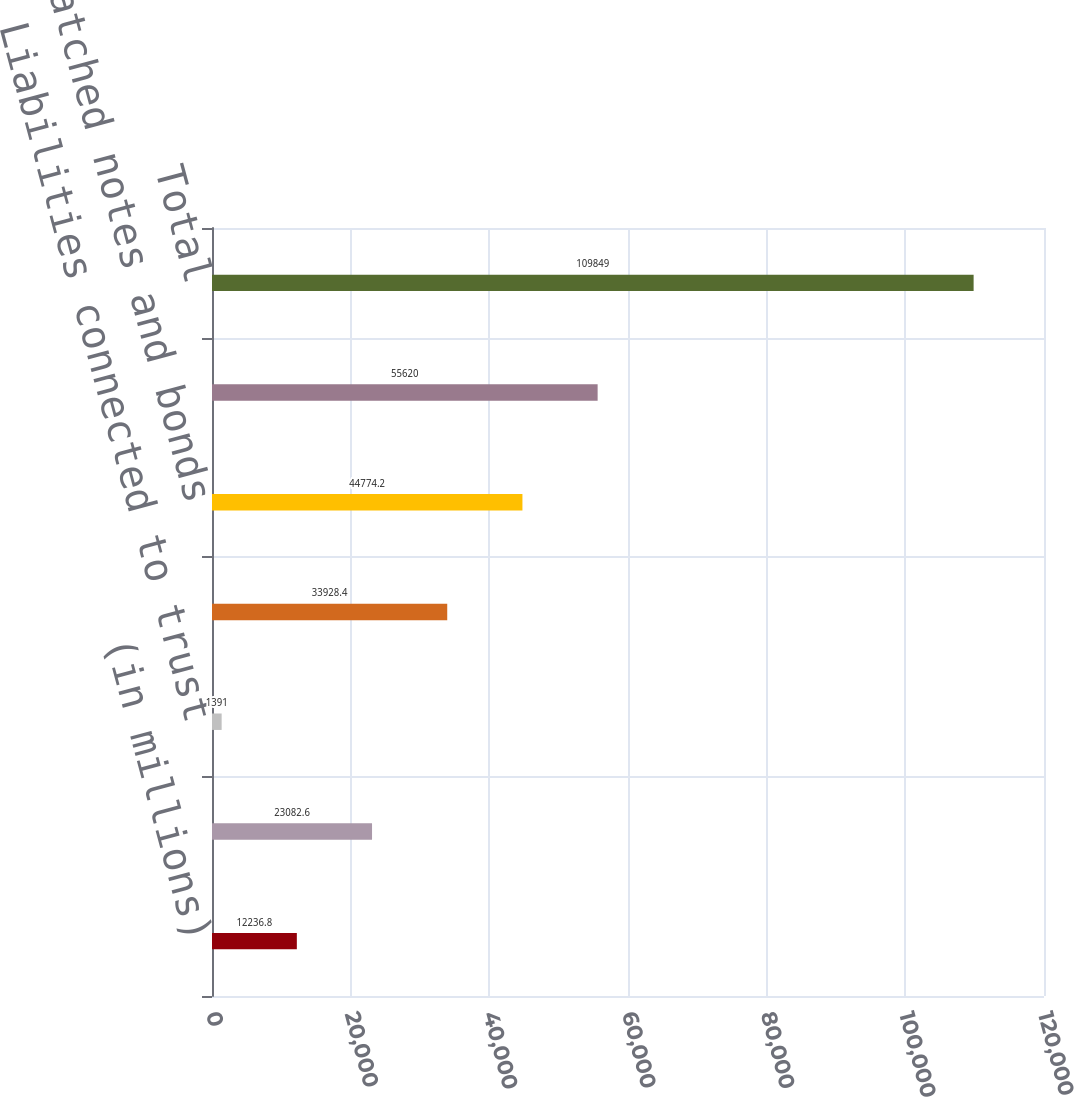<chart> <loc_0><loc_0><loc_500><loc_500><bar_chart><fcel>(in millions)<fcel>AIG's net borrowings<fcel>Liabilities connected to trust<fcel>GIAs<fcel>Matched notes and bonds<fcel>Borrowings not guaranteed by<fcel>Total<nl><fcel>12236.8<fcel>23082.6<fcel>1391<fcel>33928.4<fcel>44774.2<fcel>55620<fcel>109849<nl></chart> 